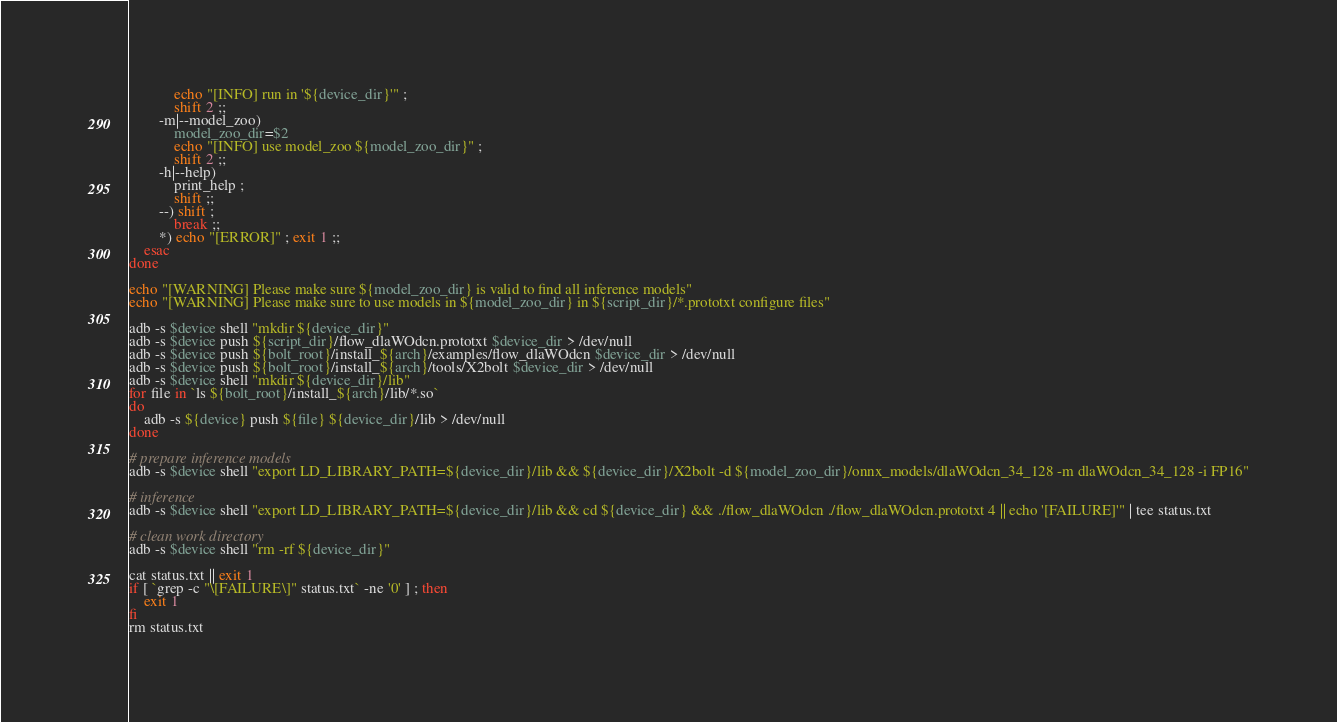<code> <loc_0><loc_0><loc_500><loc_500><_Bash_>            echo "[INFO] run in '${device_dir}'" ;
            shift 2 ;;
        -m|--model_zoo)
            model_zoo_dir=$2
            echo "[INFO] use model_zoo ${model_zoo_dir}" ;
            shift 2 ;;
        -h|--help)
            print_help ;
            shift ;;
        --) shift ;
            break ;;
        *) echo "[ERROR]" ; exit 1 ;;
    esac
done

echo "[WARNING] Please make sure ${model_zoo_dir} is valid to find all inference models"
echo "[WARNING] Please make sure to use models in ${model_zoo_dir} in ${script_dir}/*.prototxt configure files"

adb -s $device shell "mkdir ${device_dir}"
adb -s $device push ${script_dir}/flow_dlaWOdcn.prototxt $device_dir > /dev/null
adb -s $device push ${bolt_root}/install_${arch}/examples/flow_dlaWOdcn $device_dir > /dev/null
adb -s $device push ${bolt_root}/install_${arch}/tools/X2bolt $device_dir > /dev/null
adb -s $device shell "mkdir ${device_dir}/lib"
for file in `ls ${bolt_root}/install_${arch}/lib/*.so`
do
    adb -s ${device} push ${file} ${device_dir}/lib > /dev/null
done

# prepare inference models
adb -s $device shell "export LD_LIBRARY_PATH=${device_dir}/lib && ${device_dir}/X2bolt -d ${model_zoo_dir}/onnx_models/dlaWOdcn_34_128 -m dlaWOdcn_34_128 -i FP16"

# inference
adb -s $device shell "export LD_LIBRARY_PATH=${device_dir}/lib && cd ${device_dir} && ./flow_dlaWOdcn ./flow_dlaWOdcn.prototxt 4 || echo '[FAILURE]'" | tee status.txt

# clean work directory
adb -s $device shell "rm -rf ${device_dir}"

cat status.txt || exit 1
if [ `grep -c "\[FAILURE\]" status.txt` -ne '0' ] ; then
    exit 1
fi
rm status.txt
</code> 